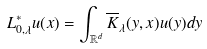Convert formula to latex. <formula><loc_0><loc_0><loc_500><loc_500>L ^ { * } _ { 0 , \lambda } u ( x ) = \int _ { \mathbb { R } ^ { d } } \overline { K } _ { \lambda } ( y , x ) u ( y ) d y</formula> 